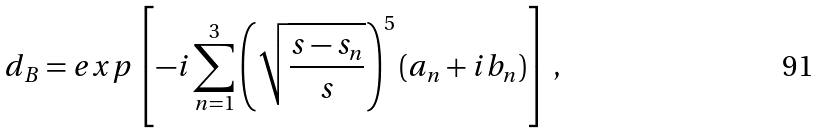<formula> <loc_0><loc_0><loc_500><loc_500>d _ { B } = e x p \left [ - i \sum _ { n = 1 } ^ { 3 } \left ( \sqrt { \frac { s - s _ { n } } { s } } \right ) ^ { 5 } ( a _ { n } + i b _ { n } ) \right ] \, ,</formula> 